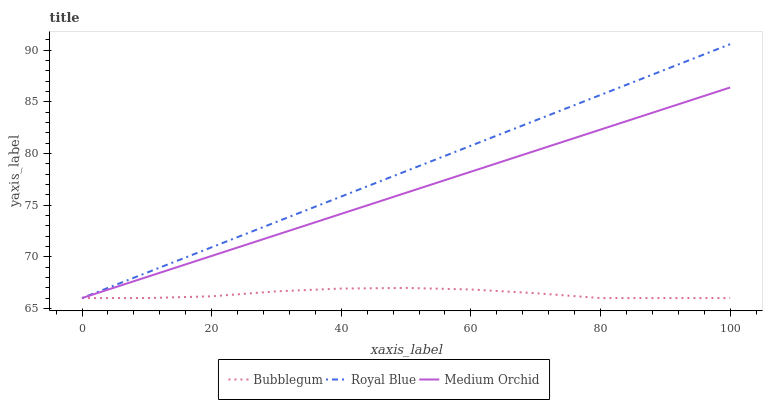Does Bubblegum have the minimum area under the curve?
Answer yes or no. Yes. Does Royal Blue have the maximum area under the curve?
Answer yes or no. Yes. Does Medium Orchid have the minimum area under the curve?
Answer yes or no. No. Does Medium Orchid have the maximum area under the curve?
Answer yes or no. No. Is Royal Blue the smoothest?
Answer yes or no. Yes. Is Bubblegum the roughest?
Answer yes or no. Yes. Is Medium Orchid the smoothest?
Answer yes or no. No. Is Medium Orchid the roughest?
Answer yes or no. No. Does Royal Blue have the highest value?
Answer yes or no. Yes. Does Medium Orchid have the highest value?
Answer yes or no. No. Does Royal Blue intersect Medium Orchid?
Answer yes or no. Yes. Is Royal Blue less than Medium Orchid?
Answer yes or no. No. Is Royal Blue greater than Medium Orchid?
Answer yes or no. No. 